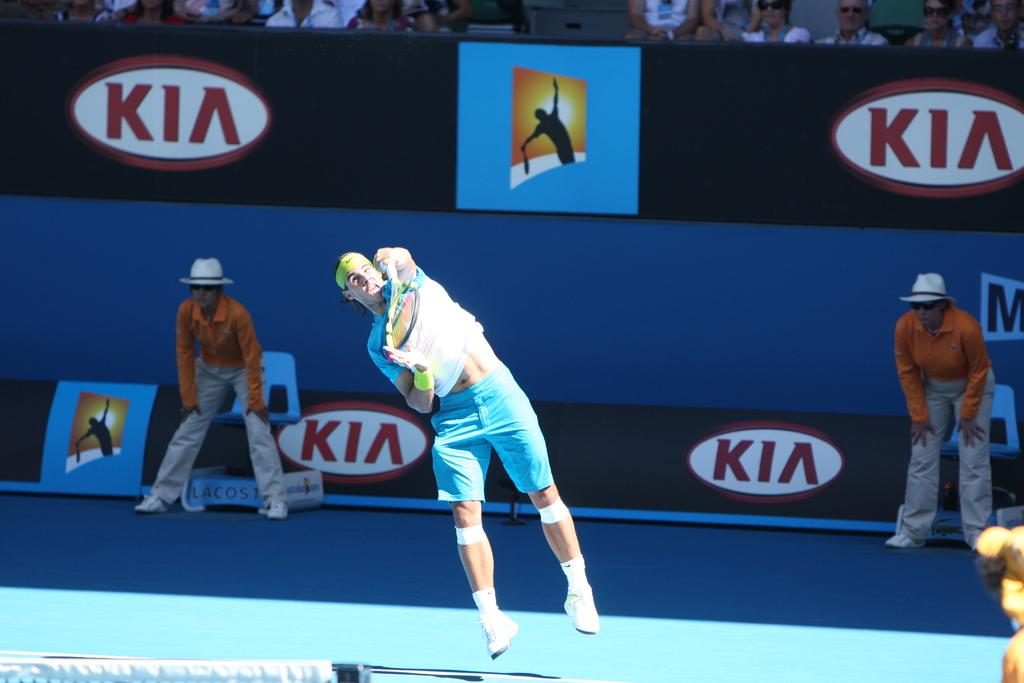What is the man in the image doing? The man is playing tennis in the image. Where is the man playing tennis? The man is in a tennis court. Are there any spectators in the image? Yes, there are two people standing and watching the game. How many dimes are visible on the tennis court? There are no dimes visible in the image; it features a man playing tennis in a tennis court with spectators. 